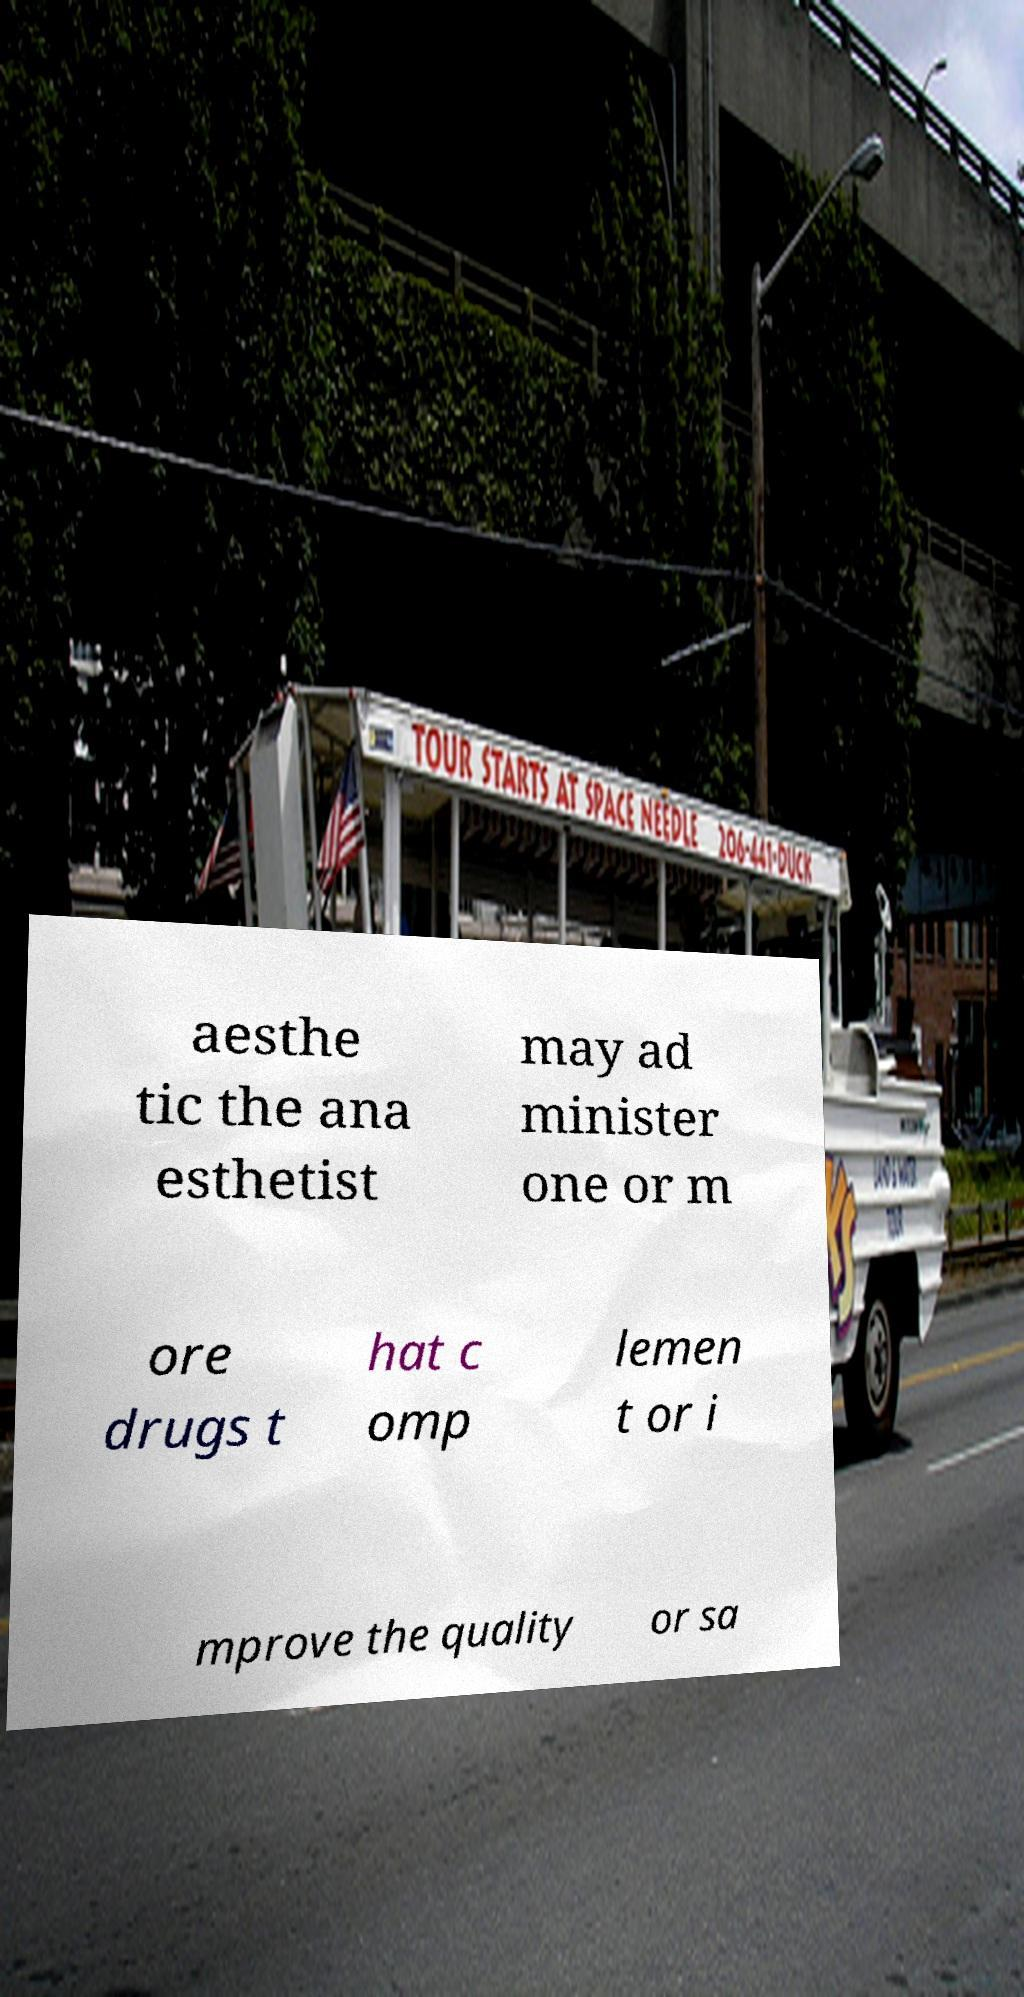Please identify and transcribe the text found in this image. aesthe tic the ana esthetist may ad minister one or m ore drugs t hat c omp lemen t or i mprove the quality or sa 